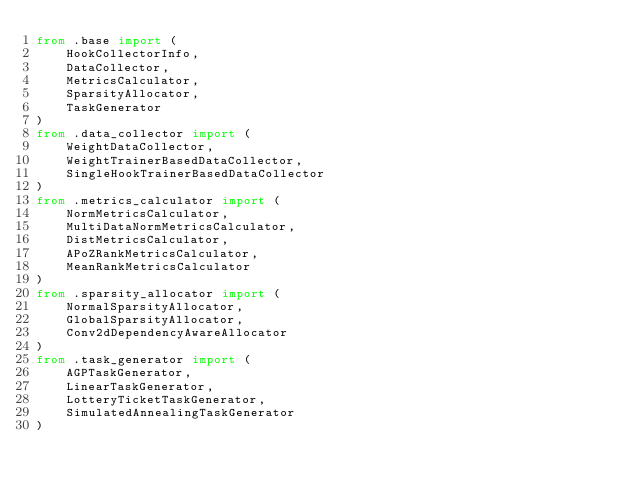<code> <loc_0><loc_0><loc_500><loc_500><_Python_>from .base import (
    HookCollectorInfo,
    DataCollector,
    MetricsCalculator,
    SparsityAllocator,
    TaskGenerator
)
from .data_collector import (
    WeightDataCollector,
    WeightTrainerBasedDataCollector,
    SingleHookTrainerBasedDataCollector
)
from .metrics_calculator import (
    NormMetricsCalculator,
    MultiDataNormMetricsCalculator,
    DistMetricsCalculator,
    APoZRankMetricsCalculator,
    MeanRankMetricsCalculator
)
from .sparsity_allocator import (
    NormalSparsityAllocator,
    GlobalSparsityAllocator,
    Conv2dDependencyAwareAllocator
)
from .task_generator import (
    AGPTaskGenerator,
    LinearTaskGenerator,
    LotteryTicketTaskGenerator,
    SimulatedAnnealingTaskGenerator
)
</code> 